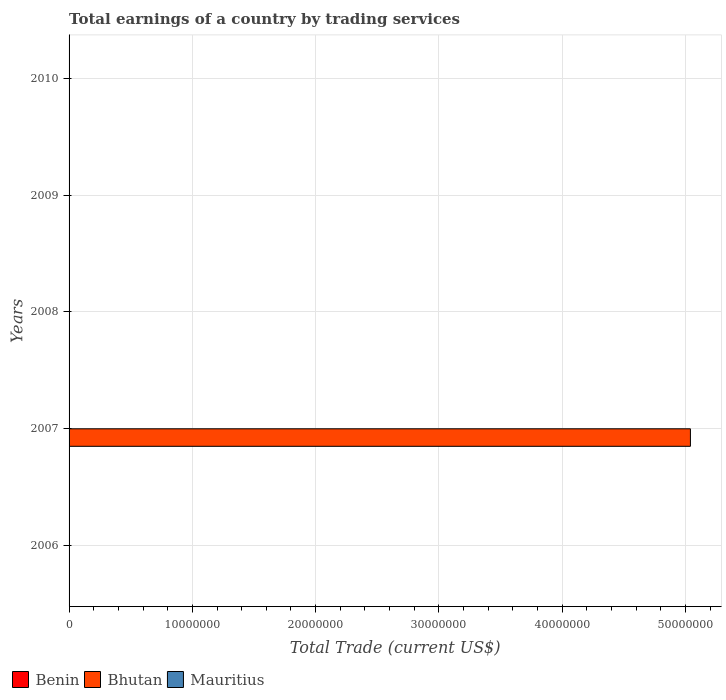How many bars are there on the 1st tick from the bottom?
Your answer should be compact. 0. What is the total earnings in Bhutan in 2007?
Your answer should be very brief. 5.04e+07. Across all years, what is the maximum total earnings in Bhutan?
Your answer should be compact. 5.04e+07. Across all years, what is the minimum total earnings in Mauritius?
Offer a very short reply. 0. In which year was the total earnings in Bhutan maximum?
Ensure brevity in your answer.  2007. What is the total total earnings in Bhutan in the graph?
Offer a very short reply. 5.04e+07. What is the difference between the total earnings in Mauritius in 2010 and the total earnings in Benin in 2008?
Your answer should be very brief. 0. What is the average total earnings in Mauritius per year?
Your response must be concise. 0. What is the difference between the highest and the lowest total earnings in Bhutan?
Provide a short and direct response. 5.04e+07. In how many years, is the total earnings in Bhutan greater than the average total earnings in Bhutan taken over all years?
Ensure brevity in your answer.  1. Are all the bars in the graph horizontal?
Make the answer very short. Yes. What is the difference between two consecutive major ticks on the X-axis?
Make the answer very short. 1.00e+07. Are the values on the major ticks of X-axis written in scientific E-notation?
Ensure brevity in your answer.  No. Does the graph contain any zero values?
Offer a terse response. Yes. Does the graph contain grids?
Give a very brief answer. Yes. Where does the legend appear in the graph?
Offer a terse response. Bottom left. How many legend labels are there?
Provide a succinct answer. 3. What is the title of the graph?
Keep it short and to the point. Total earnings of a country by trading services. Does "Palau" appear as one of the legend labels in the graph?
Your response must be concise. No. What is the label or title of the X-axis?
Offer a very short reply. Total Trade (current US$). What is the label or title of the Y-axis?
Give a very brief answer. Years. What is the Total Trade (current US$) in Mauritius in 2006?
Your answer should be compact. 0. What is the Total Trade (current US$) of Benin in 2007?
Make the answer very short. 0. What is the Total Trade (current US$) in Bhutan in 2007?
Offer a very short reply. 5.04e+07. What is the Total Trade (current US$) in Benin in 2008?
Offer a very short reply. 0. What is the Total Trade (current US$) in Bhutan in 2008?
Make the answer very short. 0. What is the Total Trade (current US$) in Mauritius in 2008?
Your answer should be very brief. 0. What is the Total Trade (current US$) of Bhutan in 2009?
Your answer should be very brief. 0. What is the Total Trade (current US$) of Benin in 2010?
Provide a succinct answer. 0. Across all years, what is the maximum Total Trade (current US$) of Bhutan?
Keep it short and to the point. 5.04e+07. Across all years, what is the minimum Total Trade (current US$) in Bhutan?
Make the answer very short. 0. What is the total Total Trade (current US$) of Bhutan in the graph?
Provide a succinct answer. 5.04e+07. What is the average Total Trade (current US$) of Bhutan per year?
Your response must be concise. 1.01e+07. What is the average Total Trade (current US$) in Mauritius per year?
Your answer should be very brief. 0. What is the difference between the highest and the lowest Total Trade (current US$) of Bhutan?
Provide a succinct answer. 5.04e+07. 